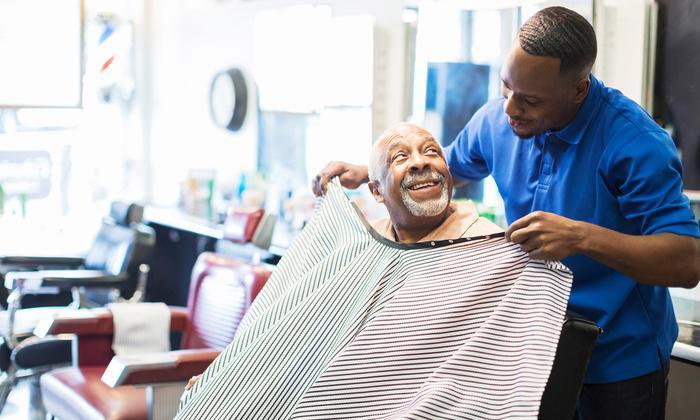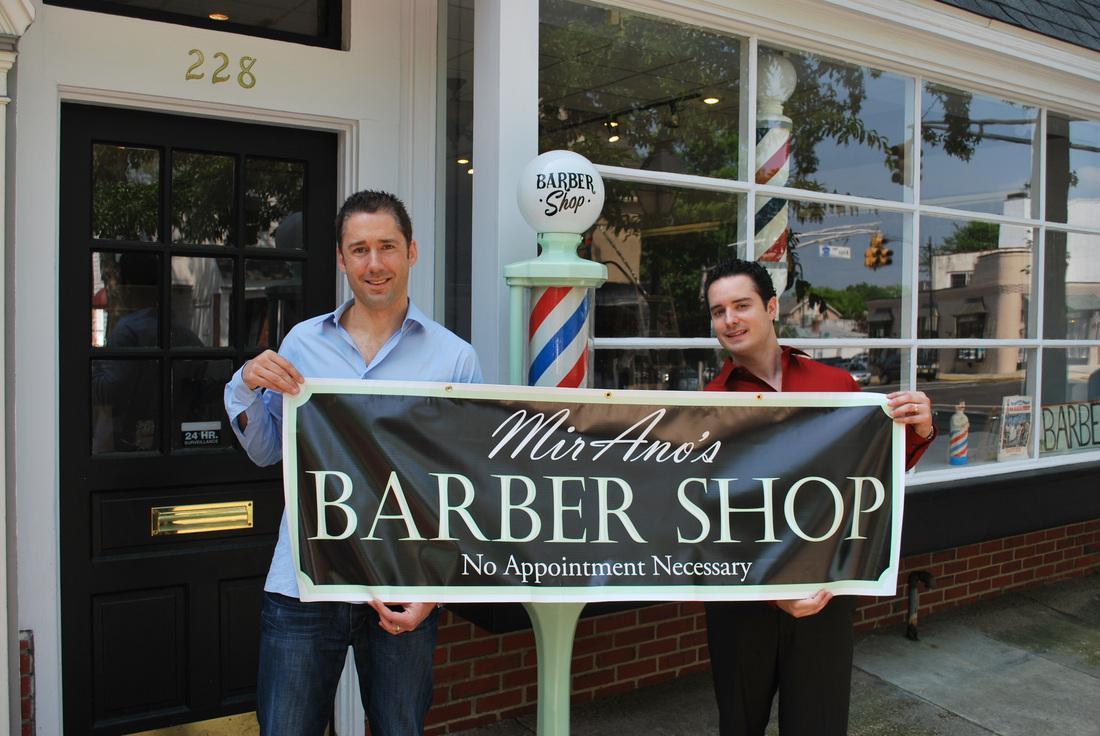The first image is the image on the left, the second image is the image on the right. For the images displayed, is the sentence "Foreground of an image shows a barber in blue by an adult male customer draped in blue." factually correct? Answer yes or no. No. The first image is the image on the left, the second image is the image on the right. Evaluate the accuracy of this statement regarding the images: "In the right image, there are two people looking straight ahead.". Is it true? Answer yes or no. Yes. 